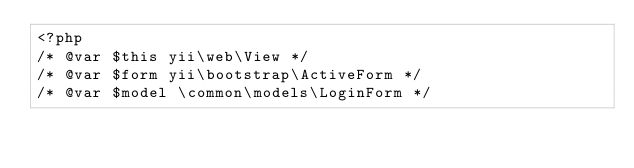Convert code to text. <code><loc_0><loc_0><loc_500><loc_500><_PHP_><?php
/* @var $this yii\web\View */
/* @var $form yii\bootstrap\ActiveForm */
/* @var $model \common\models\LoginForm */
</code> 